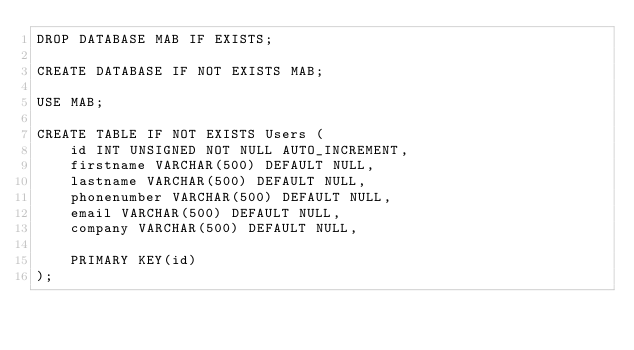Convert code to text. <code><loc_0><loc_0><loc_500><loc_500><_SQL_>DROP DATABASE MAB IF EXISTS;

CREATE DATABASE IF NOT EXISTS MAB;

USE MAB;

CREATE TABLE IF NOT EXISTS Users (
    id INT UNSIGNED NOT NULL AUTO_INCREMENT,
    firstname VARCHAR(500) DEFAULT NULL,
    lastname VARCHAR(500) DEFAULT NULL,
    phonenumber VARCHAR(500) DEFAULT NULL,
    email VARCHAR(500) DEFAULT NULL,
    company VARCHAR(500) DEFAULT NULL,

    PRIMARY KEY(id)
);</code> 